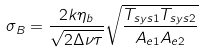<formula> <loc_0><loc_0><loc_500><loc_500>\sigma _ { B } = \frac { 2 k \eta _ { b } } { \sqrt { 2 \Delta \nu \tau } } \sqrt { \frac { T _ { s y s 1 } T _ { s y s 2 } } { A _ { e 1 } A _ { e 2 } } }</formula> 